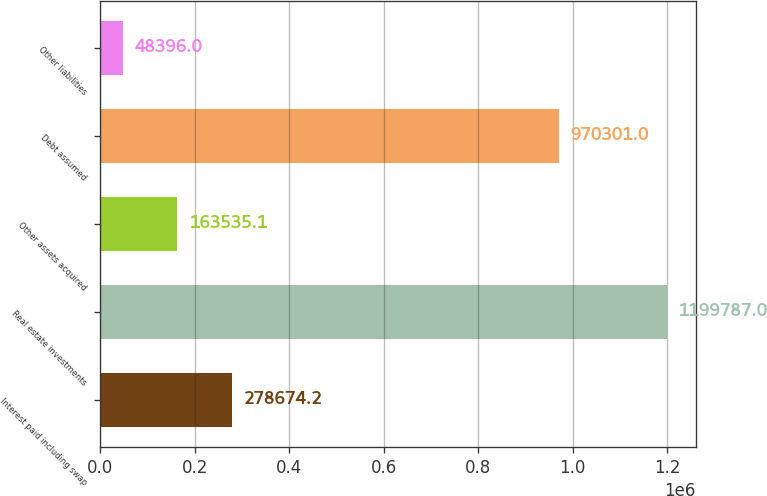Convert chart to OTSL. <chart><loc_0><loc_0><loc_500><loc_500><bar_chart><fcel>Interest paid including swap<fcel>Real estate investments<fcel>Other assets acquired<fcel>Debt assumed<fcel>Other liabilities<nl><fcel>278674<fcel>1.19979e+06<fcel>163535<fcel>970301<fcel>48396<nl></chart> 